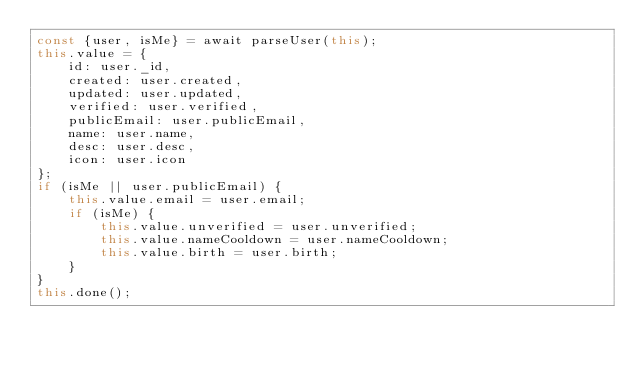<code> <loc_0><loc_0><loc_500><loc_500><_JavaScript_>const {user, isMe} = await parseUser(this);
this.value = {
	id: user._id,
	created: user.created,
	updated: user.updated,
	verified: user.verified,
	publicEmail: user.publicEmail,
	name: user.name,
	desc: user.desc,
	icon: user.icon
};
if (isMe || user.publicEmail) {
	this.value.email = user.email;
	if (isMe) {
		this.value.unverified = user.unverified;
		this.value.nameCooldown = user.nameCooldown;
		this.value.birth = user.birth;
	}
}
this.done();
</code> 